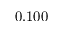<formula> <loc_0><loc_0><loc_500><loc_500>0 . 1 0 0</formula> 